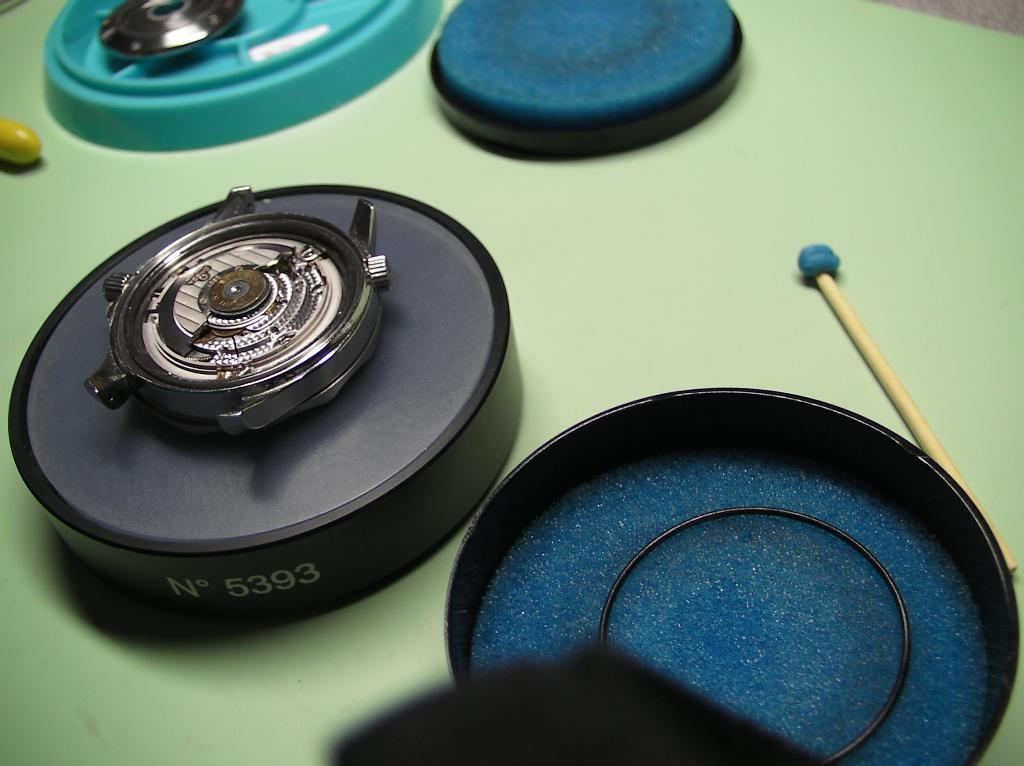Provide a one-sentence caption for the provided image. a circle item with the letter N on it and 5393. 